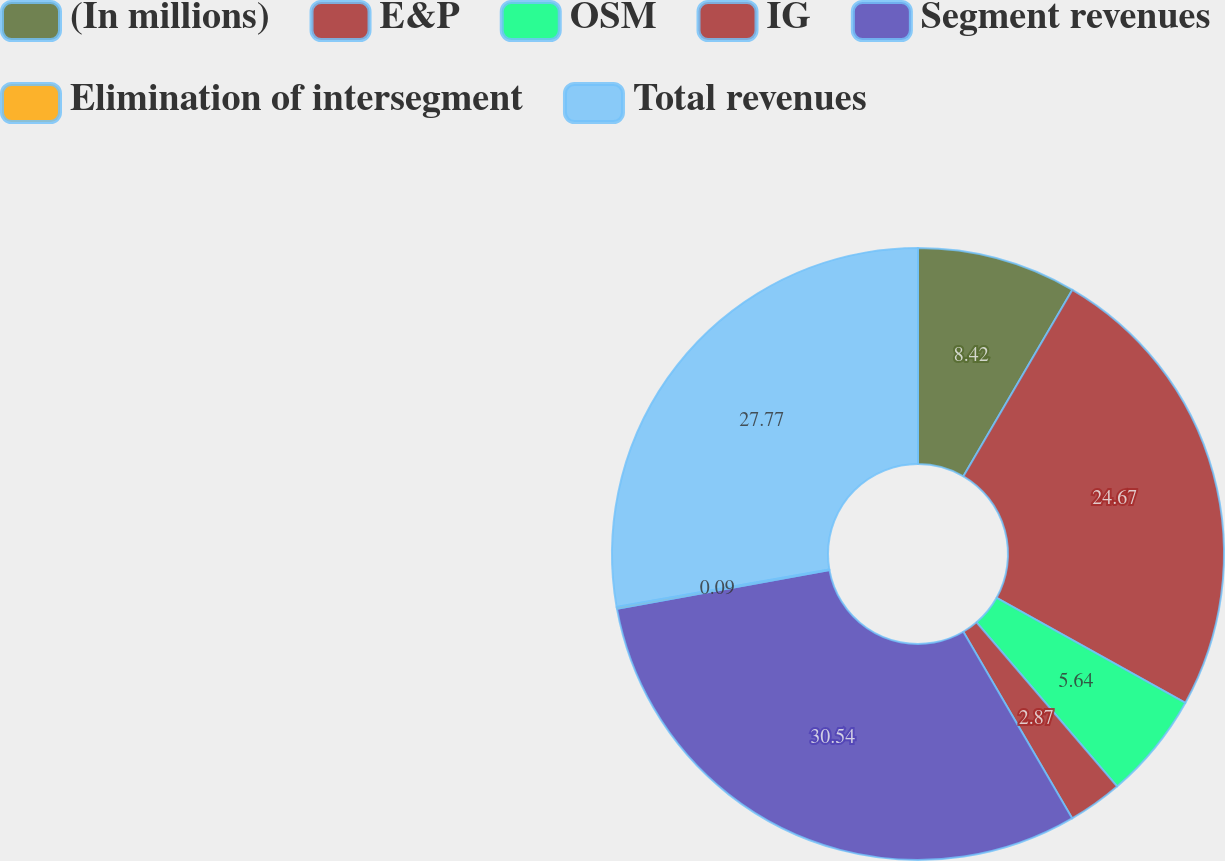Convert chart. <chart><loc_0><loc_0><loc_500><loc_500><pie_chart><fcel>(In millions)<fcel>E&P<fcel>OSM<fcel>IG<fcel>Segment revenues<fcel>Elimination of intersegment<fcel>Total revenues<nl><fcel>8.42%<fcel>24.67%<fcel>5.64%<fcel>2.87%<fcel>30.54%<fcel>0.09%<fcel>27.77%<nl></chart> 